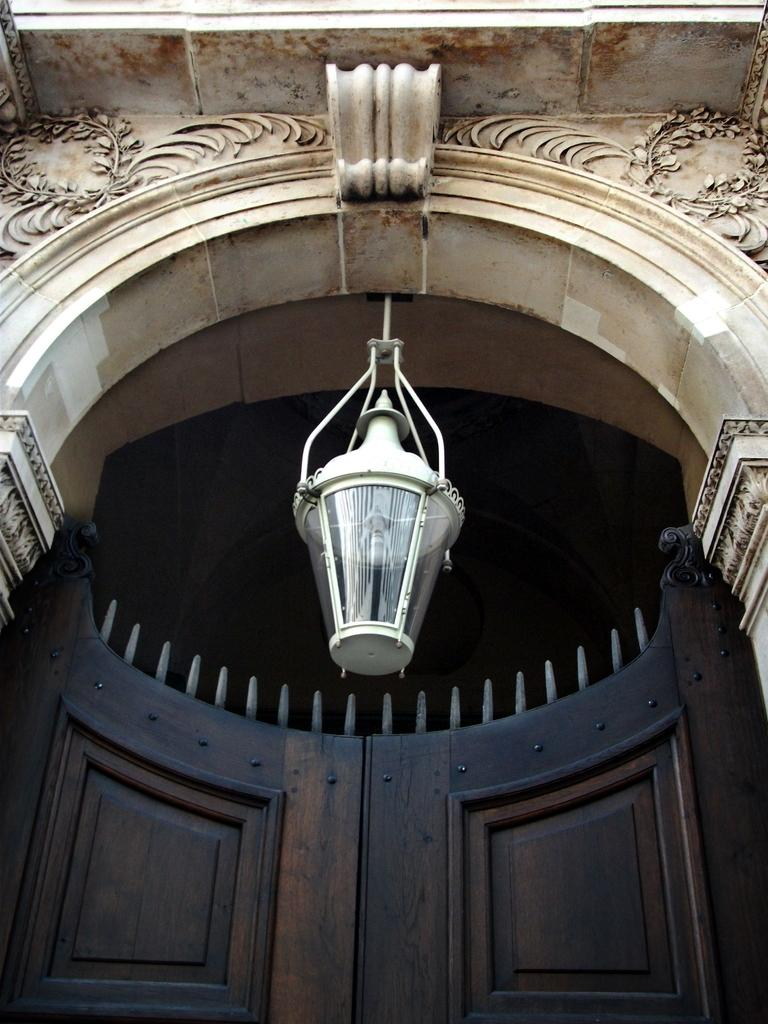What type of structure is visible in the image? There is a building in the image. Can you describe any specific features of the building? There is a lamp hanging at the entrance of the building. What type of ship can be seen sailing near the building in the image? There is no ship visible in the image; it only features a building and a lamp hanging at the entrance. How many needles are present in the image? There are no needles present in the image. 